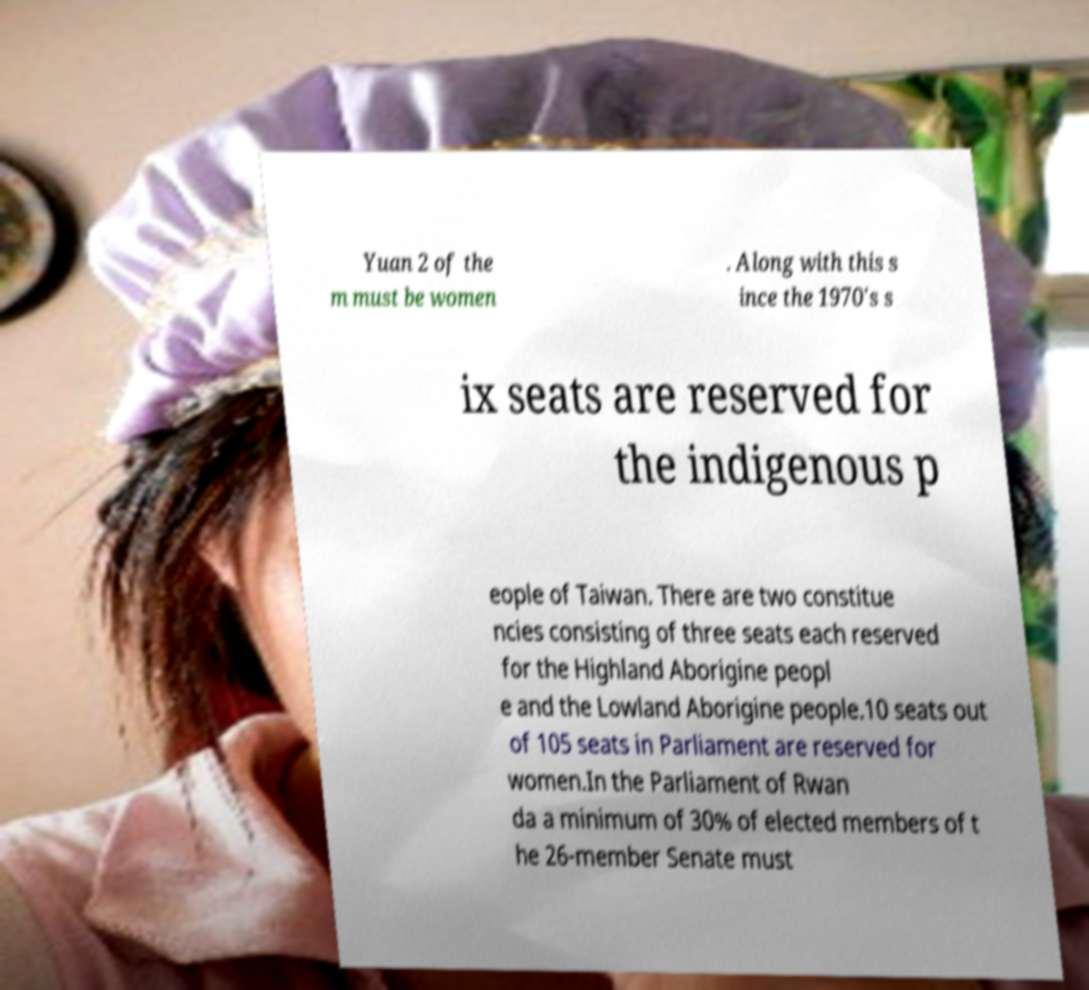Can you accurately transcribe the text from the provided image for me? Yuan 2 of the m must be women . Along with this s ince the 1970's s ix seats are reserved for the indigenous p eople of Taiwan. There are two constitue ncies consisting of three seats each reserved for the Highland Aborigine peopl e and the Lowland Aborigine people.10 seats out of 105 seats in Parliament are reserved for women.In the Parliament of Rwan da a minimum of 30% of elected members of t he 26-member Senate must 